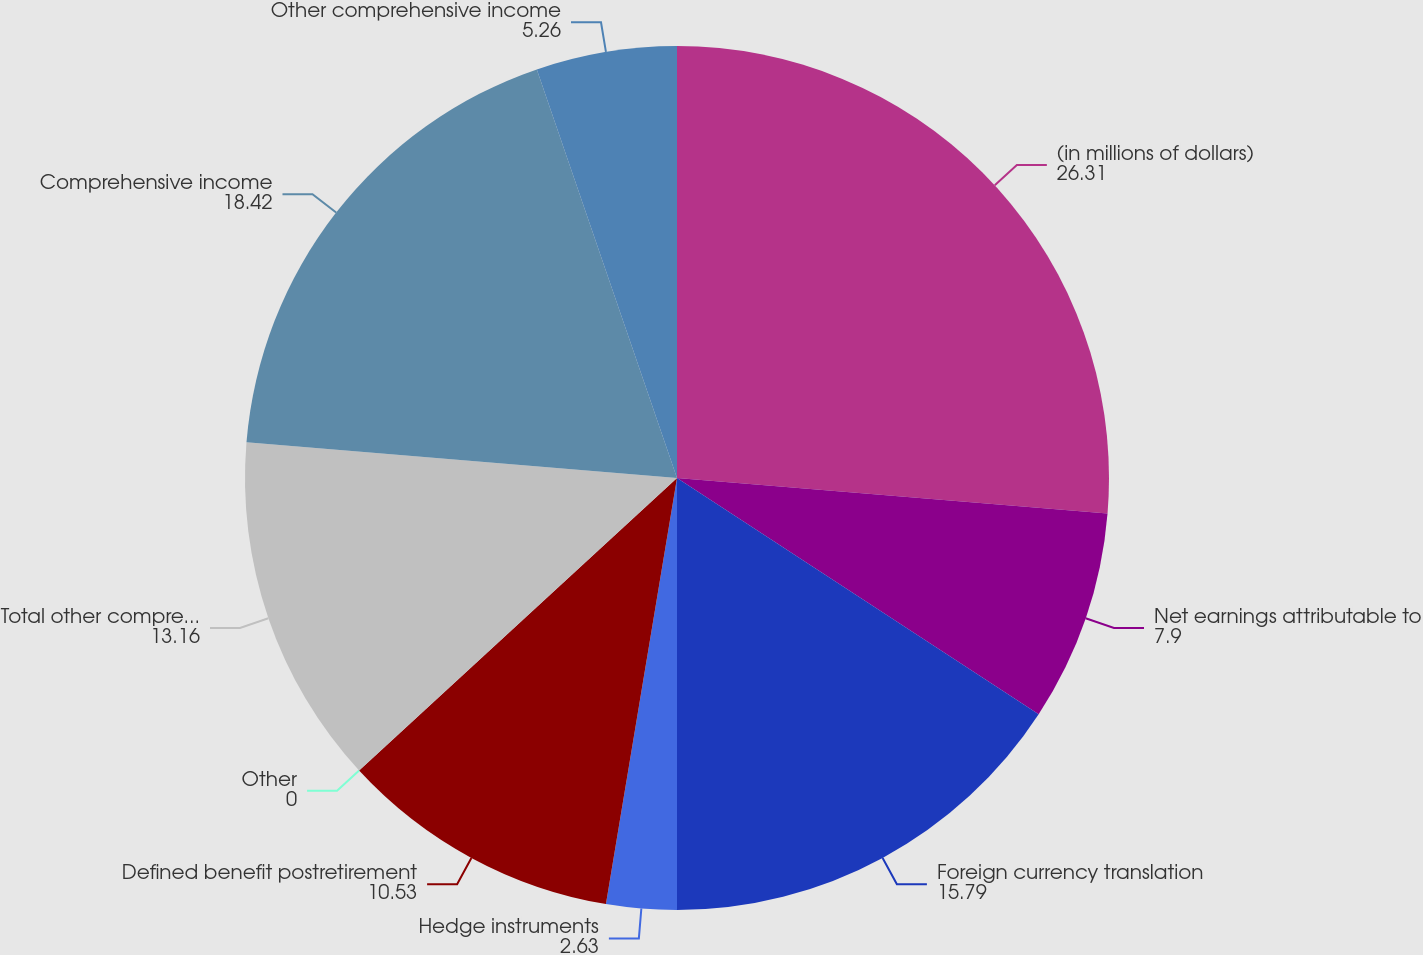<chart> <loc_0><loc_0><loc_500><loc_500><pie_chart><fcel>(in millions of dollars)<fcel>Net earnings attributable to<fcel>Foreign currency translation<fcel>Hedge instruments<fcel>Defined benefit postretirement<fcel>Other<fcel>Total other comprehensive<fcel>Comprehensive income<fcel>Other comprehensive income<nl><fcel>26.31%<fcel>7.9%<fcel>15.79%<fcel>2.63%<fcel>10.53%<fcel>0.0%<fcel>13.16%<fcel>18.42%<fcel>5.26%<nl></chart> 